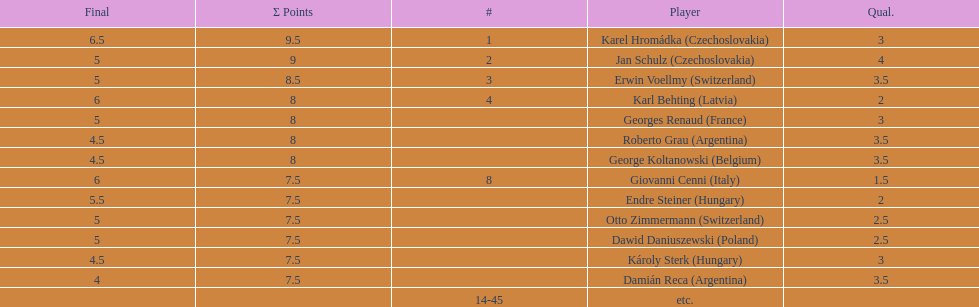How many countries had more than one player in the consolation cup? 4. 